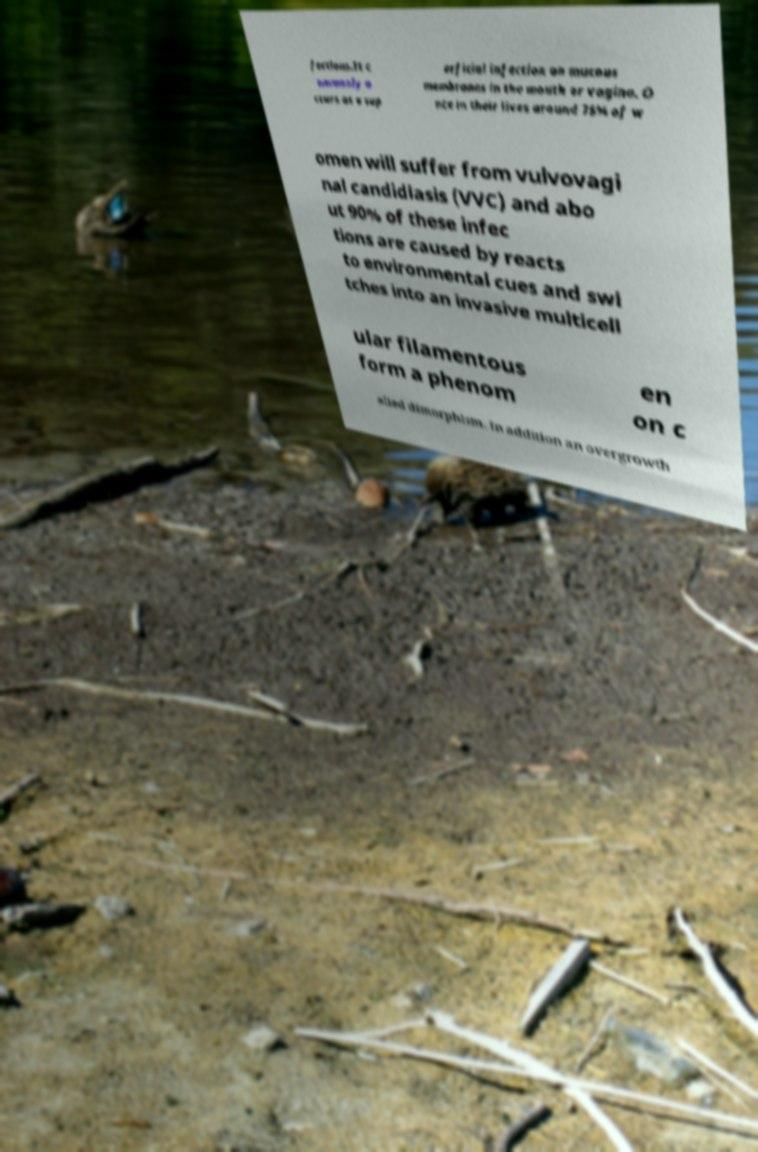What messages or text are displayed in this image? I need them in a readable, typed format. fections.It c ommonly o ccurs as a sup erficial infection on mucous membranes in the mouth or vagina. O nce in their lives around 75% of w omen will suffer from vulvovagi nal candidiasis (VVC) and abo ut 90% of these infec tions are caused by reacts to environmental cues and swi tches into an invasive multicell ular filamentous form a phenom en on c alled dimorphism. In addition an overgrowth 